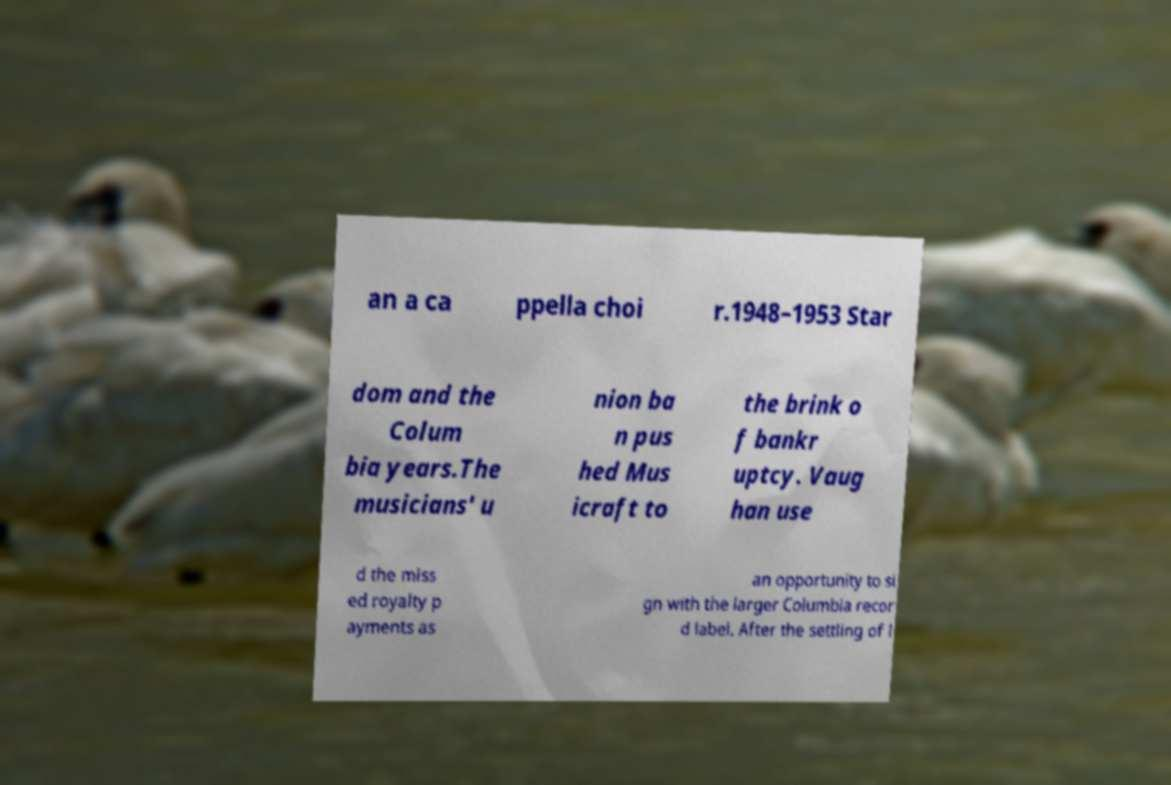Please identify and transcribe the text found in this image. an a ca ppella choi r.1948–1953 Star dom and the Colum bia years.The musicians' u nion ba n pus hed Mus icraft to the brink o f bankr uptcy. Vaug han use d the miss ed royalty p ayments as an opportunity to si gn with the larger Columbia recor d label. After the settling of l 